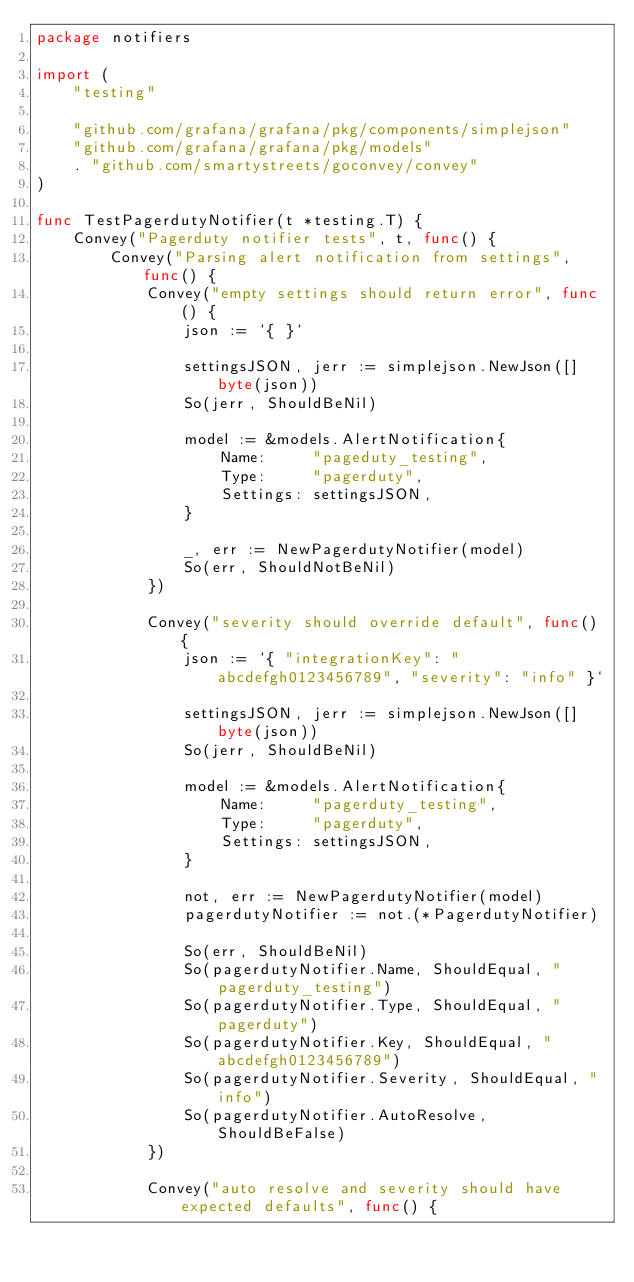<code> <loc_0><loc_0><loc_500><loc_500><_Go_>package notifiers

import (
	"testing"

	"github.com/grafana/grafana/pkg/components/simplejson"
	"github.com/grafana/grafana/pkg/models"
	. "github.com/smartystreets/goconvey/convey"
)

func TestPagerdutyNotifier(t *testing.T) {
	Convey("Pagerduty notifier tests", t, func() {
		Convey("Parsing alert notification from settings", func() {
			Convey("empty settings should return error", func() {
				json := `{ }`

				settingsJSON, jerr := simplejson.NewJson([]byte(json))
				So(jerr, ShouldBeNil)

				model := &models.AlertNotification{
					Name:     "pageduty_testing",
					Type:     "pagerduty",
					Settings: settingsJSON,
				}

				_, err := NewPagerdutyNotifier(model)
				So(err, ShouldNotBeNil)
			})

			Convey("severity should override default", func() {
				json := `{ "integrationKey": "abcdefgh0123456789", "severity": "info" }`

				settingsJSON, jerr := simplejson.NewJson([]byte(json))
				So(jerr, ShouldBeNil)

				model := &models.AlertNotification{
					Name:     "pagerduty_testing",
					Type:     "pagerduty",
					Settings: settingsJSON,
				}

				not, err := NewPagerdutyNotifier(model)
				pagerdutyNotifier := not.(*PagerdutyNotifier)

				So(err, ShouldBeNil)
				So(pagerdutyNotifier.Name, ShouldEqual, "pagerduty_testing")
				So(pagerdutyNotifier.Type, ShouldEqual, "pagerduty")
				So(pagerdutyNotifier.Key, ShouldEqual, "abcdefgh0123456789")
				So(pagerdutyNotifier.Severity, ShouldEqual, "info")
				So(pagerdutyNotifier.AutoResolve, ShouldBeFalse)
			})

			Convey("auto resolve and severity should have expected defaults", func() {</code> 